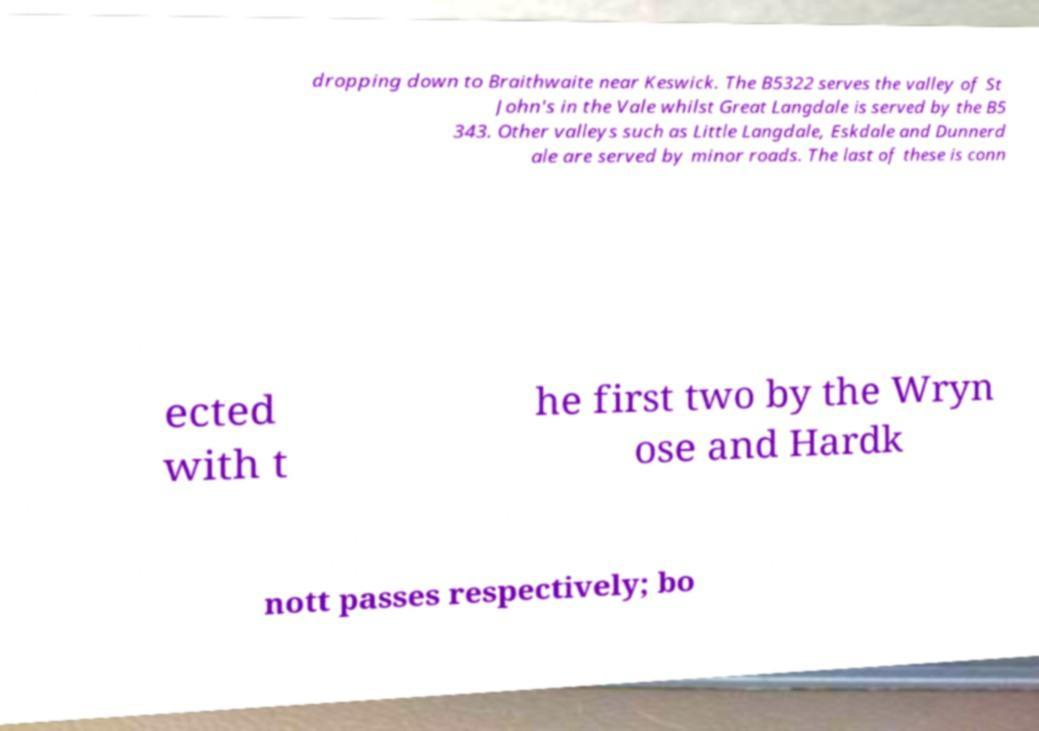What messages or text are displayed in this image? I need them in a readable, typed format. dropping down to Braithwaite near Keswick. The B5322 serves the valley of St John's in the Vale whilst Great Langdale is served by the B5 343. Other valleys such as Little Langdale, Eskdale and Dunnerd ale are served by minor roads. The last of these is conn ected with t he first two by the Wryn ose and Hardk nott passes respectively; bo 